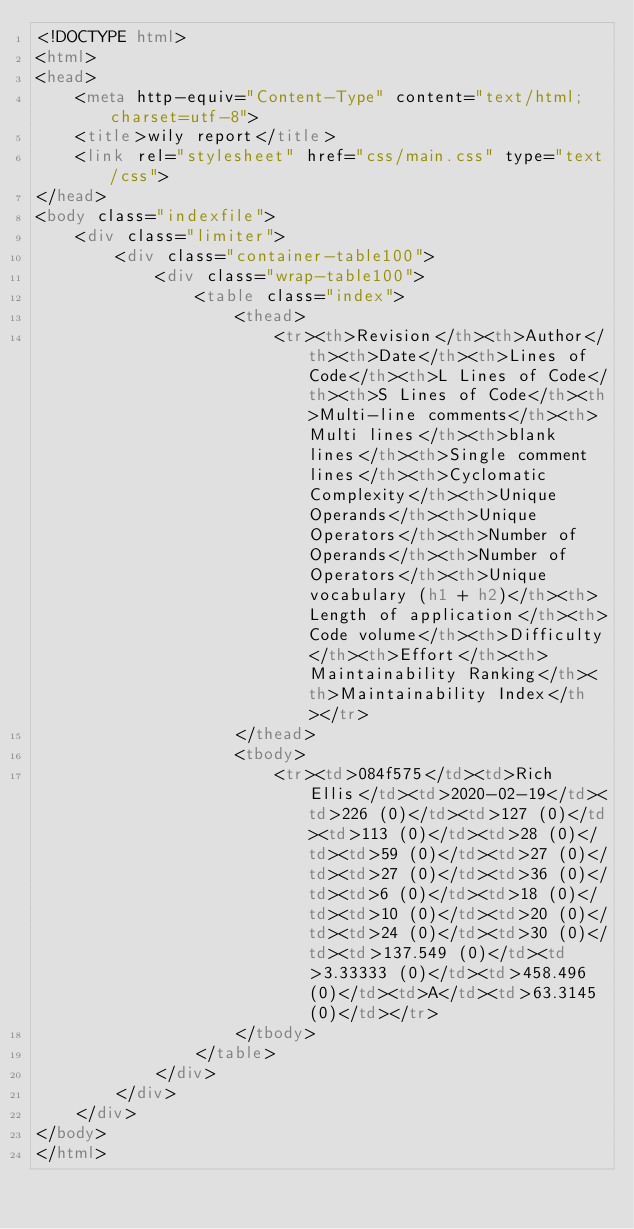Convert code to text. <code><loc_0><loc_0><loc_500><loc_500><_HTML_><!DOCTYPE html>
<html>
<head>
    <meta http-equiv="Content-Type" content="text/html; charset=utf-8">
    <title>wily report</title>
    <link rel="stylesheet" href="css/main.css" type="text/css">
</head>
<body class="indexfile">
    <div class="limiter">
		<div class="container-table100">
			<div class="wrap-table100">
                <table class="index">
                    <thead>
                        <tr><th>Revision</th><th>Author</th><th>Date</th><th>Lines of Code</th><th>L Lines of Code</th><th>S Lines of Code</th><th>Multi-line comments</th><th>Multi lines</th><th>blank lines</th><th>Single comment lines</th><th>Cyclomatic Complexity</th><th>Unique Operands</th><th>Unique Operators</th><th>Number of Operands</th><th>Number of Operators</th><th>Unique vocabulary (h1 + h2)</th><th>Length of application</th><th>Code volume</th><th>Difficulty</th><th>Effort</th><th>Maintainability Ranking</th><th>Maintainability Index</th></tr>
                    </thead>
                    <tbody>
                        <tr><td>084f575</td><td>Rich Ellis</td><td>2020-02-19</td><td>226 (0)</td><td>127 (0)</td><td>113 (0)</td><td>28 (0)</td><td>59 (0)</td><td>27 (0)</td><td>27 (0)</td><td>36 (0)</td><td>6 (0)</td><td>18 (0)</td><td>10 (0)</td><td>20 (0)</td><td>24 (0)</td><td>30 (0)</td><td>137.549 (0)</td><td>3.33333 (0)</td><td>458.496 (0)</td><td>A</td><td>63.3145 (0)</td></tr>
                    </tbody>
                </table>
            </div>
        </div>
    </div>
</body>
</html></code> 